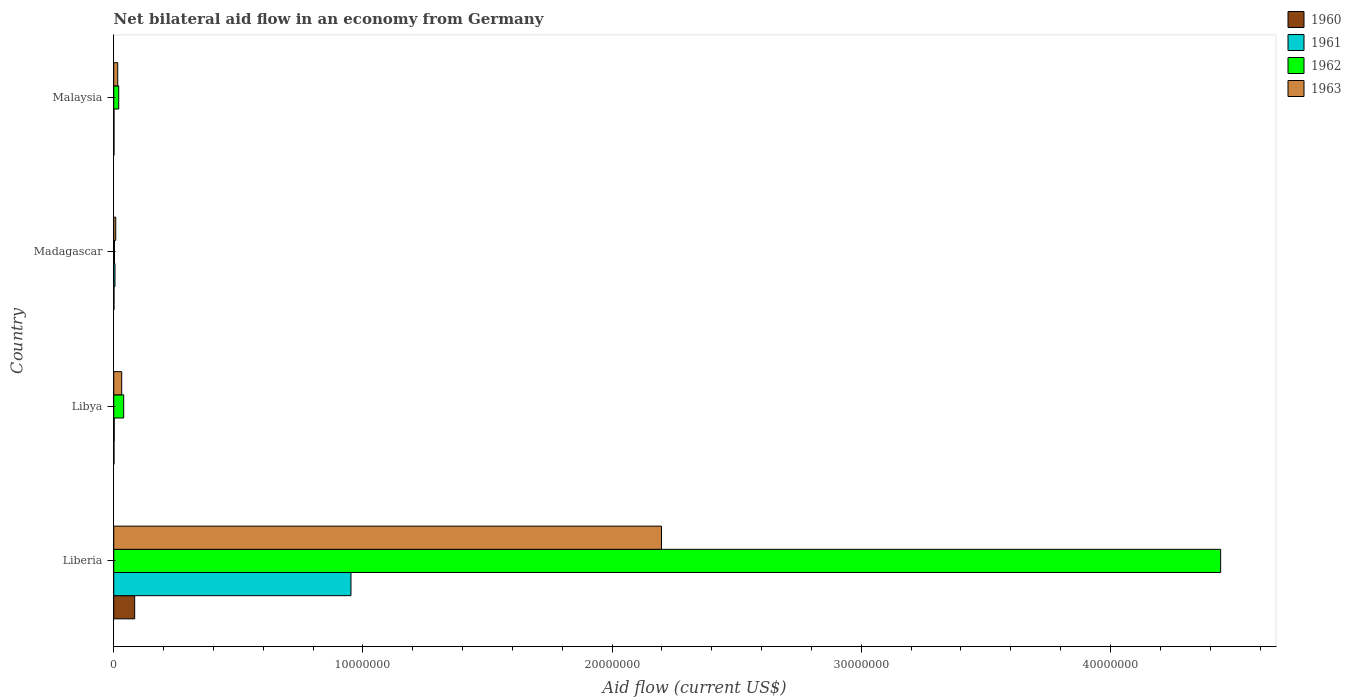How many bars are there on the 4th tick from the top?
Your response must be concise. 4. What is the label of the 1st group of bars from the top?
Offer a very short reply. Malaysia. What is the net bilateral aid flow in 1963 in Liberia?
Your answer should be compact. 2.20e+07. Across all countries, what is the maximum net bilateral aid flow in 1962?
Offer a very short reply. 4.44e+07. In which country was the net bilateral aid flow in 1961 maximum?
Provide a short and direct response. Liberia. In which country was the net bilateral aid flow in 1963 minimum?
Your response must be concise. Madagascar. What is the total net bilateral aid flow in 1960 in the graph?
Offer a terse response. 8.70e+05. What is the difference between the net bilateral aid flow in 1961 in Liberia and that in Madagascar?
Keep it short and to the point. 9.47e+06. What is the average net bilateral aid flow in 1960 per country?
Provide a short and direct response. 2.18e+05. What is the difference between the net bilateral aid flow in 1960 and net bilateral aid flow in 1963 in Liberia?
Offer a terse response. -2.11e+07. In how many countries, is the net bilateral aid flow in 1961 greater than 2000000 US$?
Make the answer very short. 1. What is the ratio of the net bilateral aid flow in 1961 in Liberia to that in Libya?
Offer a terse response. 476. Is the difference between the net bilateral aid flow in 1960 in Libya and Malaysia greater than the difference between the net bilateral aid flow in 1963 in Libya and Malaysia?
Offer a terse response. No. What is the difference between the highest and the second highest net bilateral aid flow in 1963?
Provide a succinct answer. 2.17e+07. What is the difference between the highest and the lowest net bilateral aid flow in 1960?
Keep it short and to the point. 8.30e+05. Is the sum of the net bilateral aid flow in 1962 in Madagascar and Malaysia greater than the maximum net bilateral aid flow in 1961 across all countries?
Give a very brief answer. No. Is it the case that in every country, the sum of the net bilateral aid flow in 1963 and net bilateral aid flow in 1962 is greater than the sum of net bilateral aid flow in 1961 and net bilateral aid flow in 1960?
Offer a terse response. No. What does the 4th bar from the bottom in Malaysia represents?
Your answer should be very brief. 1963. How many bars are there?
Keep it short and to the point. 16. Are all the bars in the graph horizontal?
Make the answer very short. Yes. How many countries are there in the graph?
Your response must be concise. 4. How many legend labels are there?
Provide a short and direct response. 4. What is the title of the graph?
Offer a terse response. Net bilateral aid flow in an economy from Germany. What is the label or title of the X-axis?
Provide a short and direct response. Aid flow (current US$). What is the label or title of the Y-axis?
Provide a short and direct response. Country. What is the Aid flow (current US$) of 1960 in Liberia?
Offer a terse response. 8.40e+05. What is the Aid flow (current US$) of 1961 in Liberia?
Your answer should be very brief. 9.52e+06. What is the Aid flow (current US$) in 1962 in Liberia?
Your answer should be compact. 4.44e+07. What is the Aid flow (current US$) in 1963 in Liberia?
Offer a very short reply. 2.20e+07. What is the Aid flow (current US$) in 1960 in Madagascar?
Your response must be concise. 10000. What is the Aid flow (current US$) in 1961 in Madagascar?
Offer a terse response. 5.00e+04. What is the Aid flow (current US$) of 1962 in Madagascar?
Provide a succinct answer. 3.00e+04. What is the Aid flow (current US$) in 1961 in Malaysia?
Offer a terse response. 10000. What is the Aid flow (current US$) of 1963 in Malaysia?
Provide a short and direct response. 1.60e+05. Across all countries, what is the maximum Aid flow (current US$) of 1960?
Your response must be concise. 8.40e+05. Across all countries, what is the maximum Aid flow (current US$) in 1961?
Provide a short and direct response. 9.52e+06. Across all countries, what is the maximum Aid flow (current US$) in 1962?
Your answer should be very brief. 4.44e+07. Across all countries, what is the maximum Aid flow (current US$) of 1963?
Offer a very short reply. 2.20e+07. Across all countries, what is the minimum Aid flow (current US$) in 1960?
Keep it short and to the point. 10000. Across all countries, what is the minimum Aid flow (current US$) in 1961?
Provide a short and direct response. 10000. Across all countries, what is the minimum Aid flow (current US$) in 1962?
Give a very brief answer. 3.00e+04. Across all countries, what is the minimum Aid flow (current US$) in 1963?
Ensure brevity in your answer.  8.00e+04. What is the total Aid flow (current US$) in 1960 in the graph?
Your answer should be compact. 8.70e+05. What is the total Aid flow (current US$) of 1961 in the graph?
Keep it short and to the point. 9.60e+06. What is the total Aid flow (current US$) of 1962 in the graph?
Your answer should be compact. 4.50e+07. What is the total Aid flow (current US$) in 1963 in the graph?
Offer a very short reply. 2.25e+07. What is the difference between the Aid flow (current US$) in 1960 in Liberia and that in Libya?
Provide a succinct answer. 8.30e+05. What is the difference between the Aid flow (current US$) in 1961 in Liberia and that in Libya?
Offer a terse response. 9.50e+06. What is the difference between the Aid flow (current US$) of 1962 in Liberia and that in Libya?
Your answer should be compact. 4.40e+07. What is the difference between the Aid flow (current US$) of 1963 in Liberia and that in Libya?
Your answer should be compact. 2.17e+07. What is the difference between the Aid flow (current US$) of 1960 in Liberia and that in Madagascar?
Your answer should be compact. 8.30e+05. What is the difference between the Aid flow (current US$) in 1961 in Liberia and that in Madagascar?
Provide a succinct answer. 9.47e+06. What is the difference between the Aid flow (current US$) in 1962 in Liberia and that in Madagascar?
Ensure brevity in your answer.  4.44e+07. What is the difference between the Aid flow (current US$) in 1963 in Liberia and that in Madagascar?
Ensure brevity in your answer.  2.19e+07. What is the difference between the Aid flow (current US$) of 1960 in Liberia and that in Malaysia?
Your response must be concise. 8.30e+05. What is the difference between the Aid flow (current US$) of 1961 in Liberia and that in Malaysia?
Keep it short and to the point. 9.51e+06. What is the difference between the Aid flow (current US$) in 1962 in Liberia and that in Malaysia?
Your response must be concise. 4.42e+07. What is the difference between the Aid flow (current US$) of 1963 in Liberia and that in Malaysia?
Ensure brevity in your answer.  2.18e+07. What is the difference between the Aid flow (current US$) in 1960 in Libya and that in Madagascar?
Provide a succinct answer. 0. What is the difference between the Aid flow (current US$) of 1961 in Libya and that in Madagascar?
Your answer should be very brief. -3.00e+04. What is the difference between the Aid flow (current US$) of 1960 in Libya and that in Malaysia?
Provide a short and direct response. 0. What is the difference between the Aid flow (current US$) in 1961 in Libya and that in Malaysia?
Your answer should be compact. 10000. What is the difference between the Aid flow (current US$) in 1962 in Libya and that in Malaysia?
Your response must be concise. 2.00e+05. What is the difference between the Aid flow (current US$) in 1963 in Libya and that in Malaysia?
Provide a short and direct response. 1.60e+05. What is the difference between the Aid flow (current US$) in 1960 in Madagascar and that in Malaysia?
Your answer should be very brief. 0. What is the difference between the Aid flow (current US$) of 1961 in Madagascar and that in Malaysia?
Ensure brevity in your answer.  4.00e+04. What is the difference between the Aid flow (current US$) in 1960 in Liberia and the Aid flow (current US$) in 1961 in Libya?
Your answer should be very brief. 8.20e+05. What is the difference between the Aid flow (current US$) of 1960 in Liberia and the Aid flow (current US$) of 1962 in Libya?
Give a very brief answer. 4.40e+05. What is the difference between the Aid flow (current US$) of 1960 in Liberia and the Aid flow (current US$) of 1963 in Libya?
Give a very brief answer. 5.20e+05. What is the difference between the Aid flow (current US$) in 1961 in Liberia and the Aid flow (current US$) in 1962 in Libya?
Make the answer very short. 9.12e+06. What is the difference between the Aid flow (current US$) of 1961 in Liberia and the Aid flow (current US$) of 1963 in Libya?
Make the answer very short. 9.20e+06. What is the difference between the Aid flow (current US$) of 1962 in Liberia and the Aid flow (current US$) of 1963 in Libya?
Keep it short and to the point. 4.41e+07. What is the difference between the Aid flow (current US$) of 1960 in Liberia and the Aid flow (current US$) of 1961 in Madagascar?
Offer a very short reply. 7.90e+05. What is the difference between the Aid flow (current US$) of 1960 in Liberia and the Aid flow (current US$) of 1962 in Madagascar?
Provide a succinct answer. 8.10e+05. What is the difference between the Aid flow (current US$) of 1960 in Liberia and the Aid flow (current US$) of 1963 in Madagascar?
Your answer should be compact. 7.60e+05. What is the difference between the Aid flow (current US$) of 1961 in Liberia and the Aid flow (current US$) of 1962 in Madagascar?
Ensure brevity in your answer.  9.49e+06. What is the difference between the Aid flow (current US$) of 1961 in Liberia and the Aid flow (current US$) of 1963 in Madagascar?
Make the answer very short. 9.44e+06. What is the difference between the Aid flow (current US$) in 1962 in Liberia and the Aid flow (current US$) in 1963 in Madagascar?
Keep it short and to the point. 4.43e+07. What is the difference between the Aid flow (current US$) of 1960 in Liberia and the Aid flow (current US$) of 1961 in Malaysia?
Provide a short and direct response. 8.30e+05. What is the difference between the Aid flow (current US$) in 1960 in Liberia and the Aid flow (current US$) in 1962 in Malaysia?
Your answer should be very brief. 6.40e+05. What is the difference between the Aid flow (current US$) in 1960 in Liberia and the Aid flow (current US$) in 1963 in Malaysia?
Offer a very short reply. 6.80e+05. What is the difference between the Aid flow (current US$) of 1961 in Liberia and the Aid flow (current US$) of 1962 in Malaysia?
Give a very brief answer. 9.32e+06. What is the difference between the Aid flow (current US$) of 1961 in Liberia and the Aid flow (current US$) of 1963 in Malaysia?
Provide a succinct answer. 9.36e+06. What is the difference between the Aid flow (current US$) of 1962 in Liberia and the Aid flow (current US$) of 1963 in Malaysia?
Give a very brief answer. 4.43e+07. What is the difference between the Aid flow (current US$) of 1960 in Libya and the Aid flow (current US$) of 1963 in Madagascar?
Your answer should be very brief. -7.00e+04. What is the difference between the Aid flow (current US$) of 1961 in Libya and the Aid flow (current US$) of 1962 in Madagascar?
Make the answer very short. -10000. What is the difference between the Aid flow (current US$) in 1961 in Libya and the Aid flow (current US$) in 1962 in Malaysia?
Your answer should be very brief. -1.80e+05. What is the difference between the Aid flow (current US$) of 1962 in Libya and the Aid flow (current US$) of 1963 in Malaysia?
Offer a terse response. 2.40e+05. What is the difference between the Aid flow (current US$) of 1960 in Madagascar and the Aid flow (current US$) of 1961 in Malaysia?
Offer a very short reply. 0. What is the difference between the Aid flow (current US$) of 1960 in Madagascar and the Aid flow (current US$) of 1962 in Malaysia?
Make the answer very short. -1.90e+05. What is the difference between the Aid flow (current US$) in 1961 in Madagascar and the Aid flow (current US$) in 1963 in Malaysia?
Your response must be concise. -1.10e+05. What is the difference between the Aid flow (current US$) of 1962 in Madagascar and the Aid flow (current US$) of 1963 in Malaysia?
Your answer should be very brief. -1.30e+05. What is the average Aid flow (current US$) of 1960 per country?
Provide a succinct answer. 2.18e+05. What is the average Aid flow (current US$) in 1961 per country?
Your answer should be very brief. 2.40e+06. What is the average Aid flow (current US$) in 1962 per country?
Your response must be concise. 1.13e+07. What is the average Aid flow (current US$) of 1963 per country?
Give a very brief answer. 5.64e+06. What is the difference between the Aid flow (current US$) of 1960 and Aid flow (current US$) of 1961 in Liberia?
Your response must be concise. -8.68e+06. What is the difference between the Aid flow (current US$) of 1960 and Aid flow (current US$) of 1962 in Liberia?
Offer a very short reply. -4.36e+07. What is the difference between the Aid flow (current US$) in 1960 and Aid flow (current US$) in 1963 in Liberia?
Your response must be concise. -2.11e+07. What is the difference between the Aid flow (current US$) in 1961 and Aid flow (current US$) in 1962 in Liberia?
Provide a succinct answer. -3.49e+07. What is the difference between the Aid flow (current US$) of 1961 and Aid flow (current US$) of 1963 in Liberia?
Make the answer very short. -1.25e+07. What is the difference between the Aid flow (current US$) of 1962 and Aid flow (current US$) of 1963 in Liberia?
Offer a terse response. 2.24e+07. What is the difference between the Aid flow (current US$) of 1960 and Aid flow (current US$) of 1962 in Libya?
Your answer should be very brief. -3.90e+05. What is the difference between the Aid flow (current US$) in 1960 and Aid flow (current US$) in 1963 in Libya?
Provide a short and direct response. -3.10e+05. What is the difference between the Aid flow (current US$) of 1961 and Aid flow (current US$) of 1962 in Libya?
Your answer should be compact. -3.80e+05. What is the difference between the Aid flow (current US$) of 1961 and Aid flow (current US$) of 1962 in Madagascar?
Ensure brevity in your answer.  2.00e+04. What is the difference between the Aid flow (current US$) in 1960 and Aid flow (current US$) in 1961 in Malaysia?
Provide a short and direct response. 0. What is the difference between the Aid flow (current US$) of 1961 and Aid flow (current US$) of 1962 in Malaysia?
Your answer should be compact. -1.90e+05. What is the difference between the Aid flow (current US$) in 1962 and Aid flow (current US$) in 1963 in Malaysia?
Provide a succinct answer. 4.00e+04. What is the ratio of the Aid flow (current US$) in 1960 in Liberia to that in Libya?
Offer a very short reply. 84. What is the ratio of the Aid flow (current US$) in 1961 in Liberia to that in Libya?
Keep it short and to the point. 476. What is the ratio of the Aid flow (current US$) of 1962 in Liberia to that in Libya?
Provide a short and direct response. 111.05. What is the ratio of the Aid flow (current US$) in 1963 in Liberia to that in Libya?
Keep it short and to the point. 68.69. What is the ratio of the Aid flow (current US$) in 1960 in Liberia to that in Madagascar?
Your answer should be very brief. 84. What is the ratio of the Aid flow (current US$) of 1961 in Liberia to that in Madagascar?
Provide a short and direct response. 190.4. What is the ratio of the Aid flow (current US$) of 1962 in Liberia to that in Madagascar?
Provide a short and direct response. 1480.67. What is the ratio of the Aid flow (current US$) of 1963 in Liberia to that in Madagascar?
Your answer should be very brief. 274.75. What is the ratio of the Aid flow (current US$) of 1961 in Liberia to that in Malaysia?
Your answer should be compact. 952. What is the ratio of the Aid flow (current US$) of 1962 in Liberia to that in Malaysia?
Provide a succinct answer. 222.1. What is the ratio of the Aid flow (current US$) in 1963 in Liberia to that in Malaysia?
Offer a terse response. 137.38. What is the ratio of the Aid flow (current US$) in 1962 in Libya to that in Madagascar?
Make the answer very short. 13.33. What is the ratio of the Aid flow (current US$) of 1960 in Libya to that in Malaysia?
Your response must be concise. 1. What is the ratio of the Aid flow (current US$) of 1962 in Libya to that in Malaysia?
Offer a terse response. 2. What is the ratio of the Aid flow (current US$) in 1960 in Madagascar to that in Malaysia?
Provide a succinct answer. 1. What is the ratio of the Aid flow (current US$) in 1961 in Madagascar to that in Malaysia?
Offer a very short reply. 5. What is the ratio of the Aid flow (current US$) in 1963 in Madagascar to that in Malaysia?
Keep it short and to the point. 0.5. What is the difference between the highest and the second highest Aid flow (current US$) in 1960?
Your response must be concise. 8.30e+05. What is the difference between the highest and the second highest Aid flow (current US$) of 1961?
Ensure brevity in your answer.  9.47e+06. What is the difference between the highest and the second highest Aid flow (current US$) of 1962?
Your response must be concise. 4.40e+07. What is the difference between the highest and the second highest Aid flow (current US$) in 1963?
Your response must be concise. 2.17e+07. What is the difference between the highest and the lowest Aid flow (current US$) of 1960?
Offer a very short reply. 8.30e+05. What is the difference between the highest and the lowest Aid flow (current US$) in 1961?
Provide a succinct answer. 9.51e+06. What is the difference between the highest and the lowest Aid flow (current US$) in 1962?
Offer a very short reply. 4.44e+07. What is the difference between the highest and the lowest Aid flow (current US$) in 1963?
Offer a very short reply. 2.19e+07. 